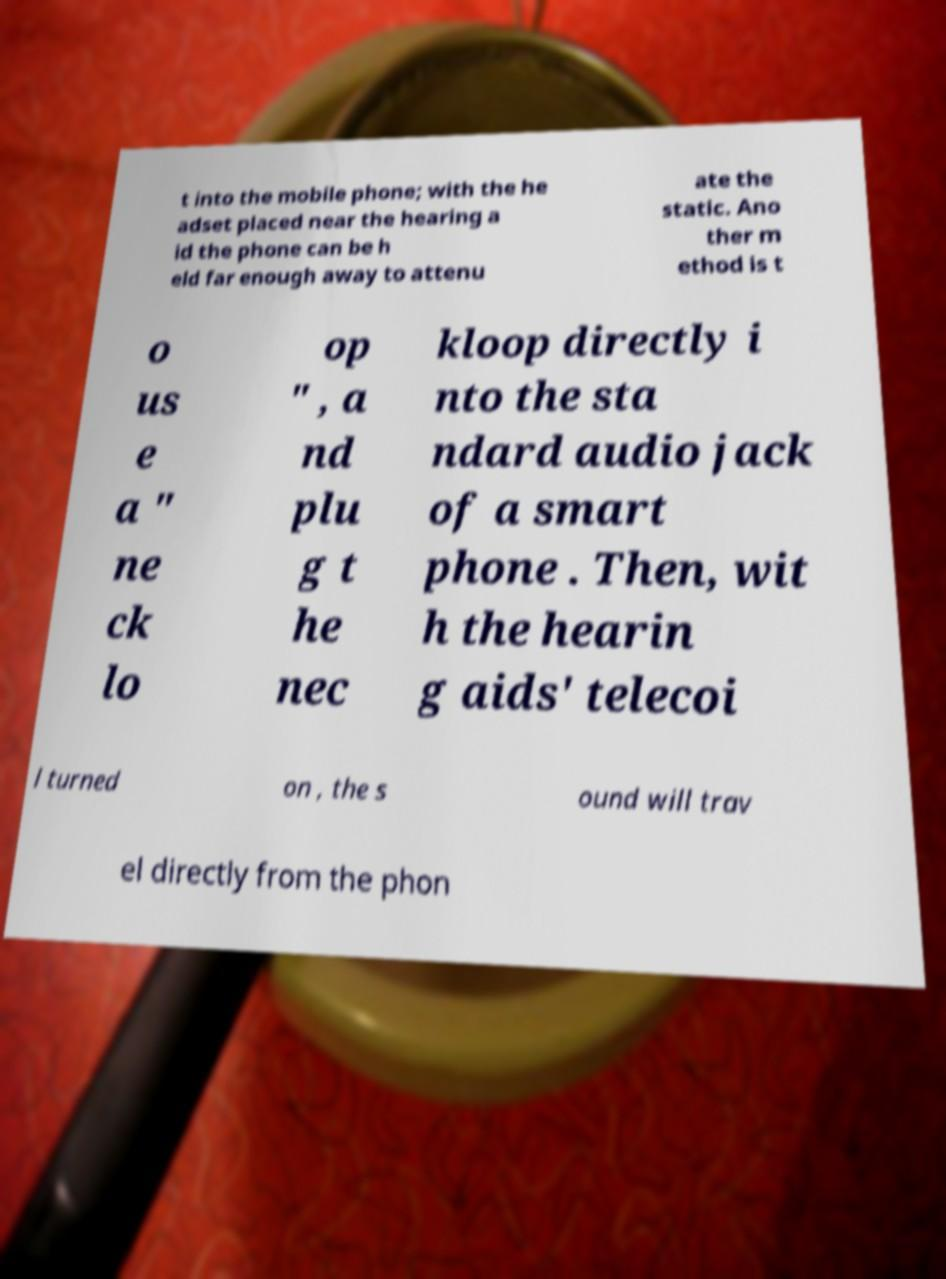Please read and relay the text visible in this image. What does it say? t into the mobile phone; with the he adset placed near the hearing a id the phone can be h eld far enough away to attenu ate the static. Ano ther m ethod is t o us e a " ne ck lo op " , a nd plu g t he nec kloop directly i nto the sta ndard audio jack of a smart phone . Then, wit h the hearin g aids' telecoi l turned on , the s ound will trav el directly from the phon 